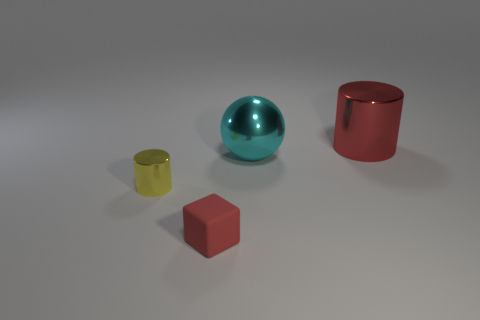Add 4 yellow objects. How many objects exist? 8 Subtract all red cylinders. How many cylinders are left? 1 Subtract all blocks. How many objects are left? 3 Subtract 1 cylinders. How many cylinders are left? 1 Add 1 matte cubes. How many matte cubes are left? 2 Add 3 small metal cylinders. How many small metal cylinders exist? 4 Subtract 0 gray blocks. How many objects are left? 4 Subtract all purple cubes. Subtract all green cylinders. How many cubes are left? 1 Subtract all brown cylinders. How many cyan blocks are left? 0 Subtract all red rubber cubes. Subtract all red objects. How many objects are left? 1 